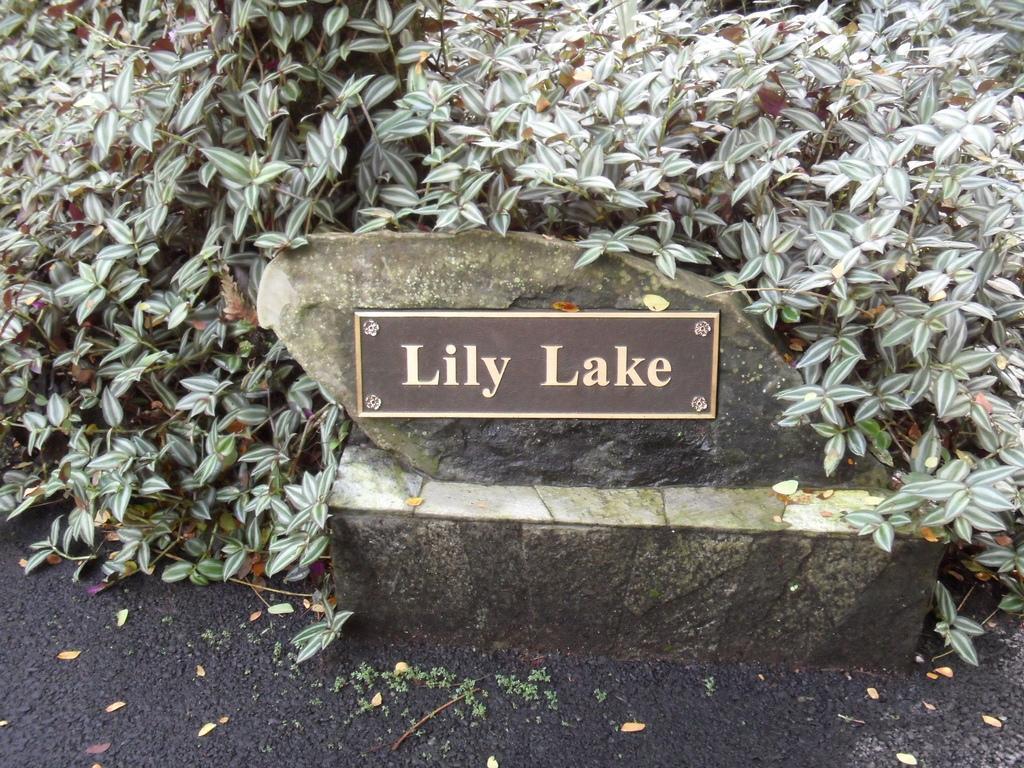In one or two sentences, can you explain what this image depicts? In this picture there is a board which is placed on the stone, beside that I can see the plants. On the left I can see many leaves. At the bottom it might be the road. 